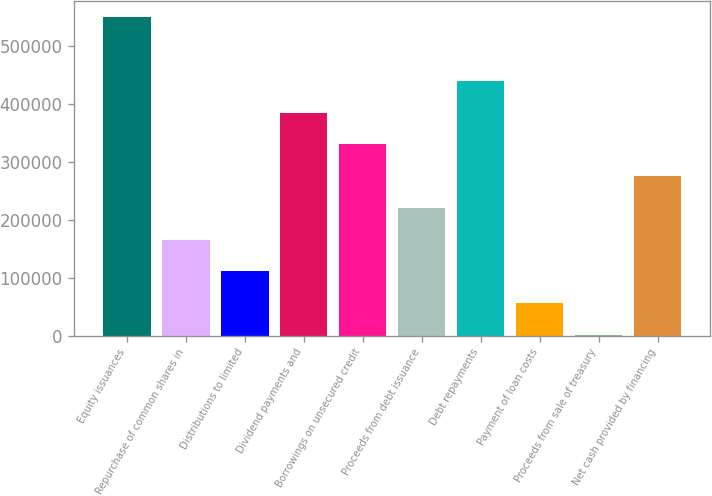<chart> <loc_0><loc_0><loc_500><loc_500><bar_chart><fcel>Equity issuances<fcel>Repurchase of common shares in<fcel>Distributions to limited<fcel>Dividend payments and<fcel>Borrowings on unsecured credit<fcel>Proceeds from debt issuance<fcel>Debt repayments<fcel>Payment of loan costs<fcel>Proceeds from sale of treasury<fcel>Net cash provided by financing<nl><fcel>548920<fcel>165326<fcel>110526<fcel>384522<fcel>329723<fcel>220125<fcel>439322<fcel>55727.2<fcel>928<fcel>274924<nl></chart> 